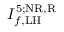Convert formula to latex. <formula><loc_0><loc_0><loc_500><loc_500>I _ { f , L H } ^ { 5 ; N R , R }</formula> 